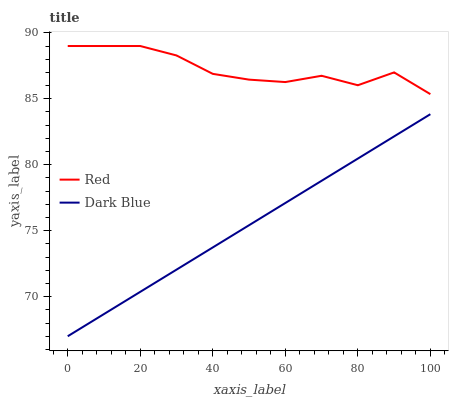Does Dark Blue have the minimum area under the curve?
Answer yes or no. Yes. Does Red have the maximum area under the curve?
Answer yes or no. Yes. Does Red have the minimum area under the curve?
Answer yes or no. No. Is Dark Blue the smoothest?
Answer yes or no. Yes. Is Red the roughest?
Answer yes or no. Yes. Is Red the smoothest?
Answer yes or no. No. Does Dark Blue have the lowest value?
Answer yes or no. Yes. Does Red have the lowest value?
Answer yes or no. No. Does Red have the highest value?
Answer yes or no. Yes. Is Dark Blue less than Red?
Answer yes or no. Yes. Is Red greater than Dark Blue?
Answer yes or no. Yes. Does Dark Blue intersect Red?
Answer yes or no. No. 